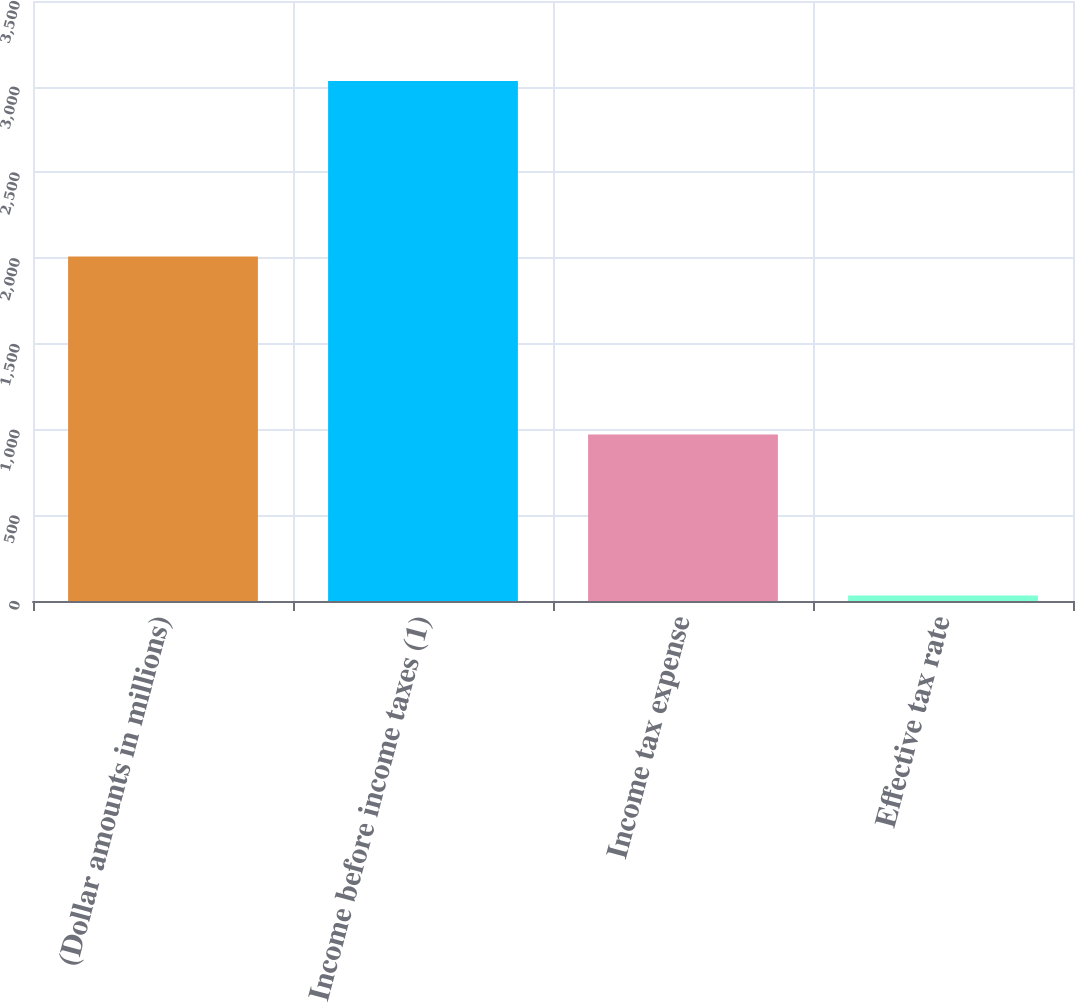Convert chart to OTSL. <chart><loc_0><loc_0><loc_500><loc_500><bar_chart><fcel>(Dollar amounts in millions)<fcel>Income before income taxes (1)<fcel>Income tax expense<fcel>Effective tax rate<nl><fcel>2010<fcel>3034<fcel>971<fcel>32<nl></chart> 